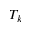<formula> <loc_0><loc_0><loc_500><loc_500>T _ { k }</formula> 